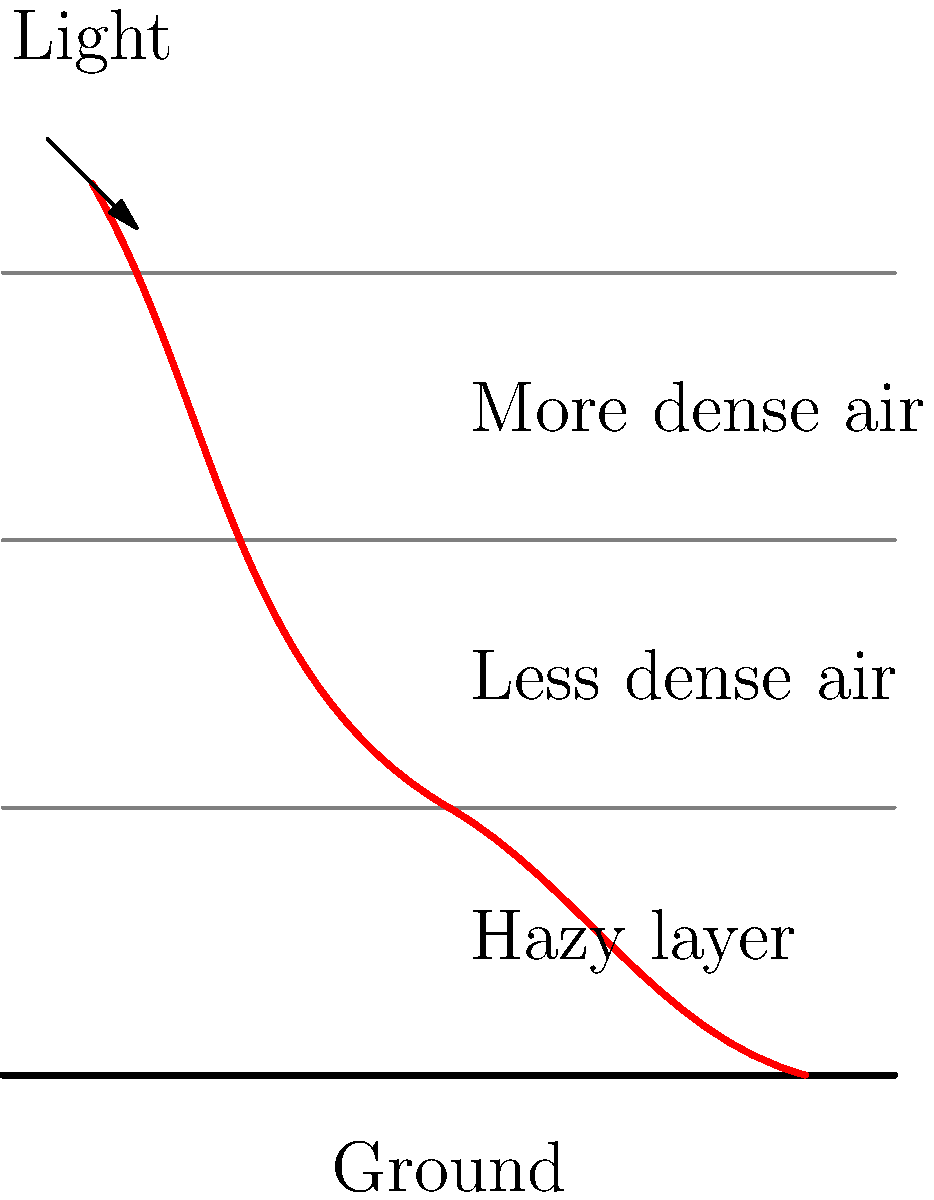During a hazy day in Johor, you notice that visibility is significantly reduced. Consider the refraction of light through different layers of the atmosphere as shown in the diagram. If the refractive index of the hazy layer near the ground is higher than the clearer air above it, how does this affect the path of light reaching an observer on the ground, and what impact does it have on visibility? To understand the effect of atmospheric refraction on visibility during haze, let's follow these steps:

1. Snell's Law: Refraction of light is governed by Snell's Law, which states that:
   $$n_1 \sin(\theta_1) = n_2 \sin(\theta_2)$$
   where $n_1$ and $n_2$ are the refractive indices of the two media, and $\theta_1$ and $\theta_2$ are the angles of incidence and refraction, respectively.

2. Atmospheric layers: In our scenario, we have:
   - Upper layer: Less dense air (lower refractive index)
   - Lower layer: Hazy air (higher refractive index)

3. Light path: As light travels from the less dense to more dense medium (hazy layer):
   - The light bends towards the normal (perpendicular to the boundary)
   - This causes the light ray to curve downwards

4. Multiple refractions: The light undergoes multiple refractions as it passes through layers of varying density, resulting in a curved path.

5. Observer's perspective: An observer on the ground perceives light coming from a direction tangent to the curved path at their location.

6. Apparent position: This makes distant objects appear higher than their actual position, an effect known as atmospheric refraction.

7. Impact on visibility:
   - The curved light path allows the observer to see slightly beyond the geometric horizon
   - However, the hazy layer scatters and absorbs light, reducing the intensity of light reaching the observer
   - This scattering and absorption significantly decrease visibility, despite the slight extension of view distance due to refraction

8. Overall effect: While refraction slightly extends the view distance, the haze's scattering and absorption properties dominate, resulting in reduced visibility.
Answer: Refraction bends light downward, slightly extending view distance, but haze's scattering and absorption significantly reduce overall visibility. 